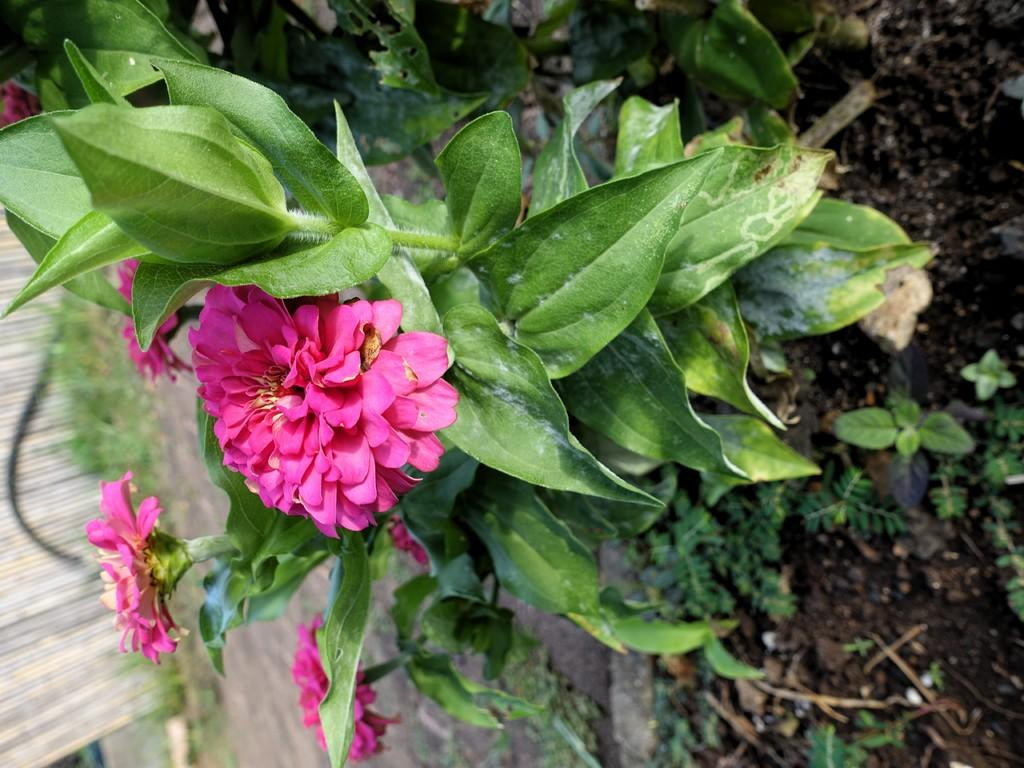What type of living organisms are present in the image? There are many plants in the image. Can you describe any specific features of the plants? There are flowers on at least one plant. What is located on the left side of the image? There is a wooden object on the left side of the image. What type of curtain can be seen hanging from the tree in the image? There is no curtain present in the image; it features plants and a wooden object. Can you describe the girl playing with the flowers in the image? There is no girl present in the image; it only contains plants and a wooden object. 